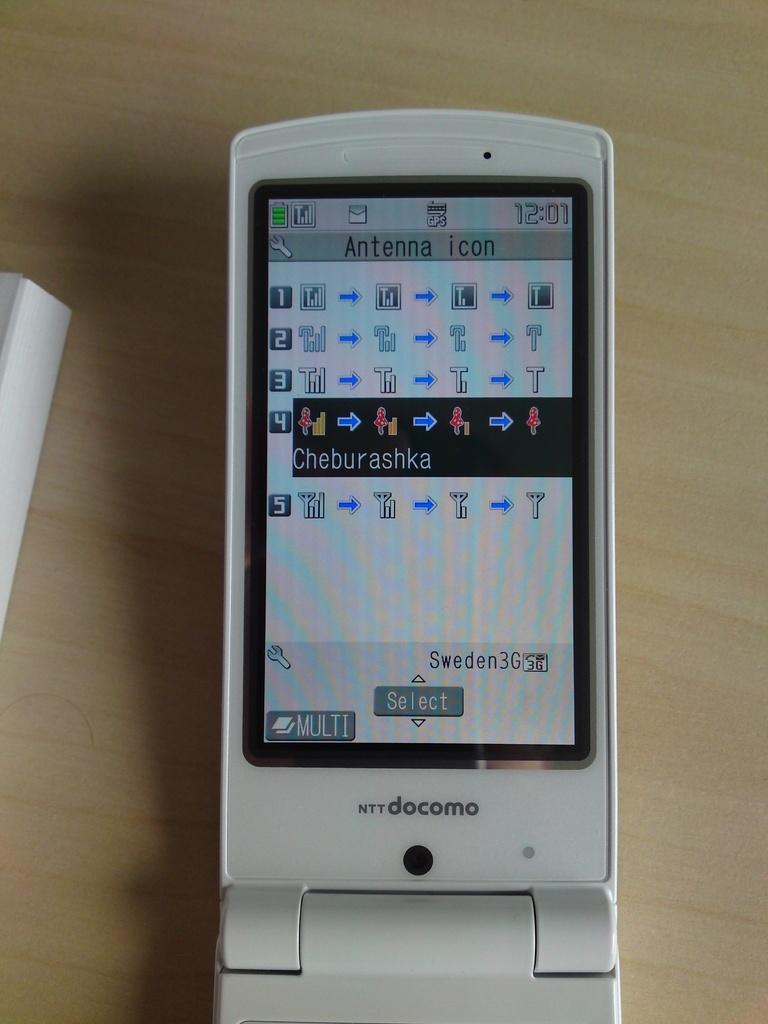<image>
Relay a brief, clear account of the picture shown. Docomo cellphone that says Antenna icon on the screen. 